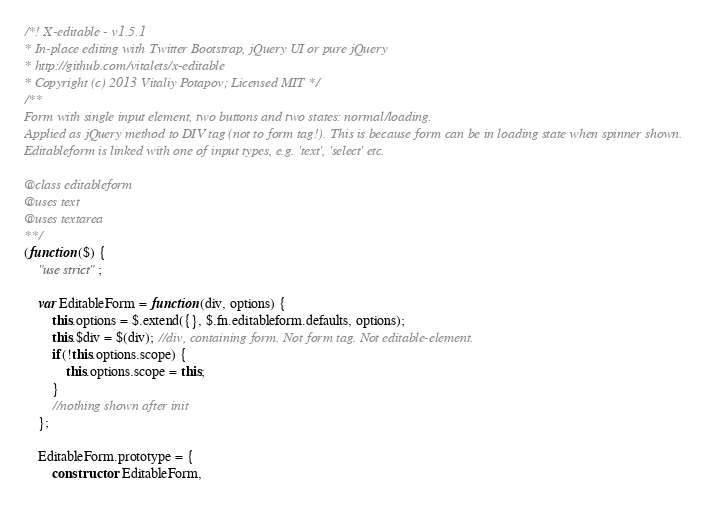<code> <loc_0><loc_0><loc_500><loc_500><_JavaScript_>/*! X-editable - v1.5.1
* In-place editing with Twitter Bootstrap, jQuery UI or pure jQuery
* http://github.com/vitalets/x-editable
* Copyright (c) 2013 Vitaliy Potapov; Licensed MIT */
/**
Form with single input element, two buttons and two states: normal/loading.
Applied as jQuery method to DIV tag (not to form tag!). This is because form can be in loading state when spinner shown.
Editableform is linked with one of input types, e.g. 'text', 'select' etc.

@class editableform
@uses text
@uses textarea
**/
(function ($) {
    "use strict";

    var EditableForm = function (div, options) {
        this.options = $.extend({}, $.fn.editableform.defaults, options);
        this.$div = $(div); //div, containing form. Not form tag. Not editable-element.
        if(!this.options.scope) {
            this.options.scope = this;
        }
        //nothing shown after init
    };

    EditableForm.prototype = {
        constructor: EditableForm,</code> 